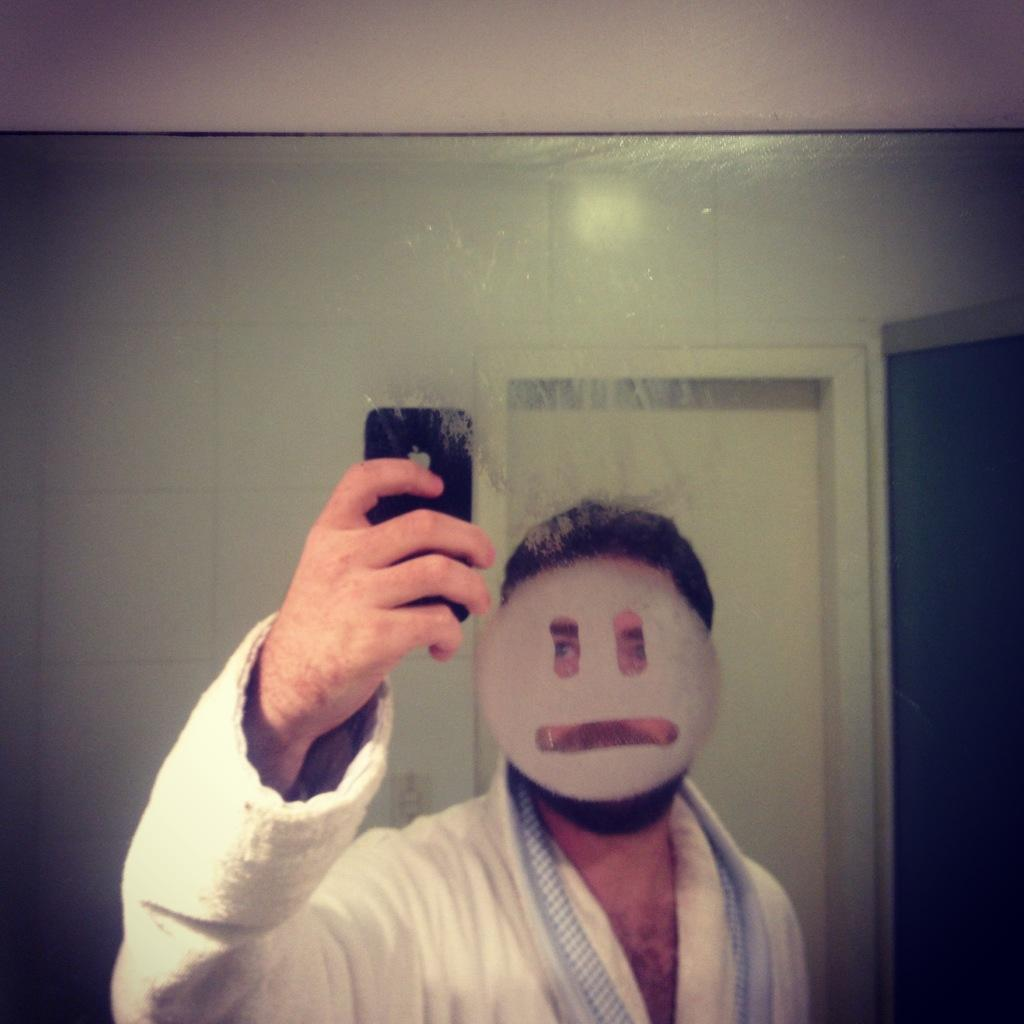What is the person in the image doing? The person is standing in front of a mirror and clicking his picture. What can be seen in the background of the image? There is a door behind the person. What is the person wearing on his face? The person is wearing a mask on his face. What type of pipe can be seen in the image? There is no pipe present in the image. What shape is the mask the person is wearing? The provided facts do not mention the shape of the mask, so we cannot determine its shape from the image. 